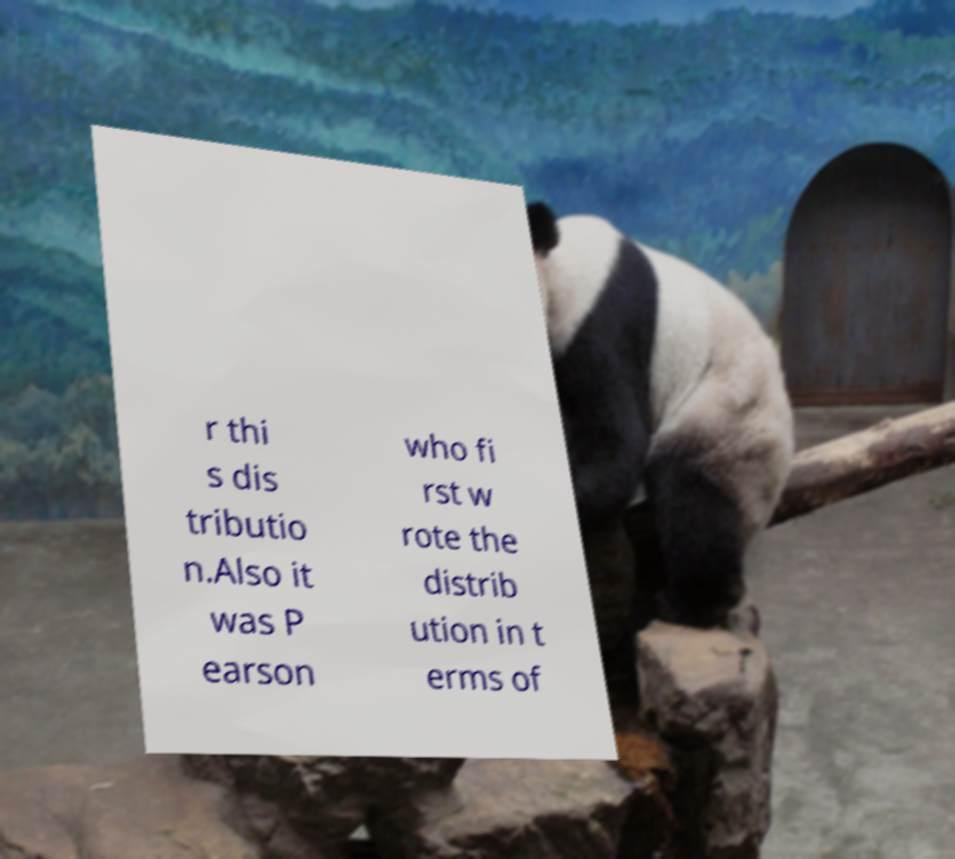Could you extract and type out the text from this image? r thi s dis tributio n.Also it was P earson who fi rst w rote the distrib ution in t erms of 